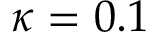<formula> <loc_0><loc_0><loc_500><loc_500>\kappa = 0 . 1</formula> 